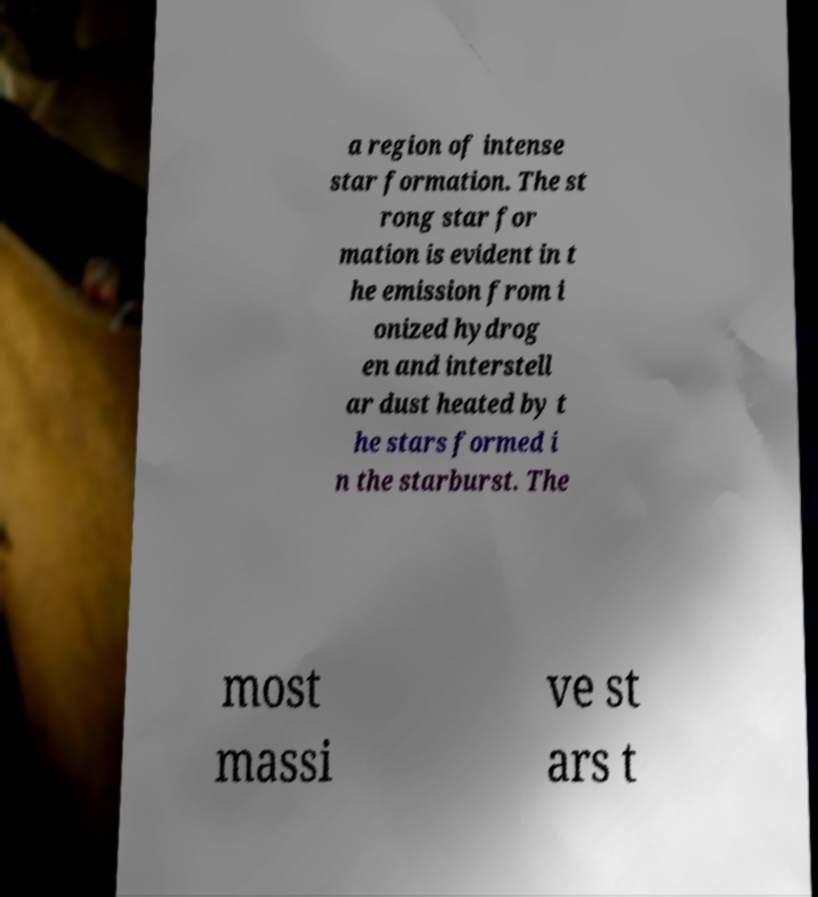There's text embedded in this image that I need extracted. Can you transcribe it verbatim? a region of intense star formation. The st rong star for mation is evident in t he emission from i onized hydrog en and interstell ar dust heated by t he stars formed i n the starburst. The most massi ve st ars t 